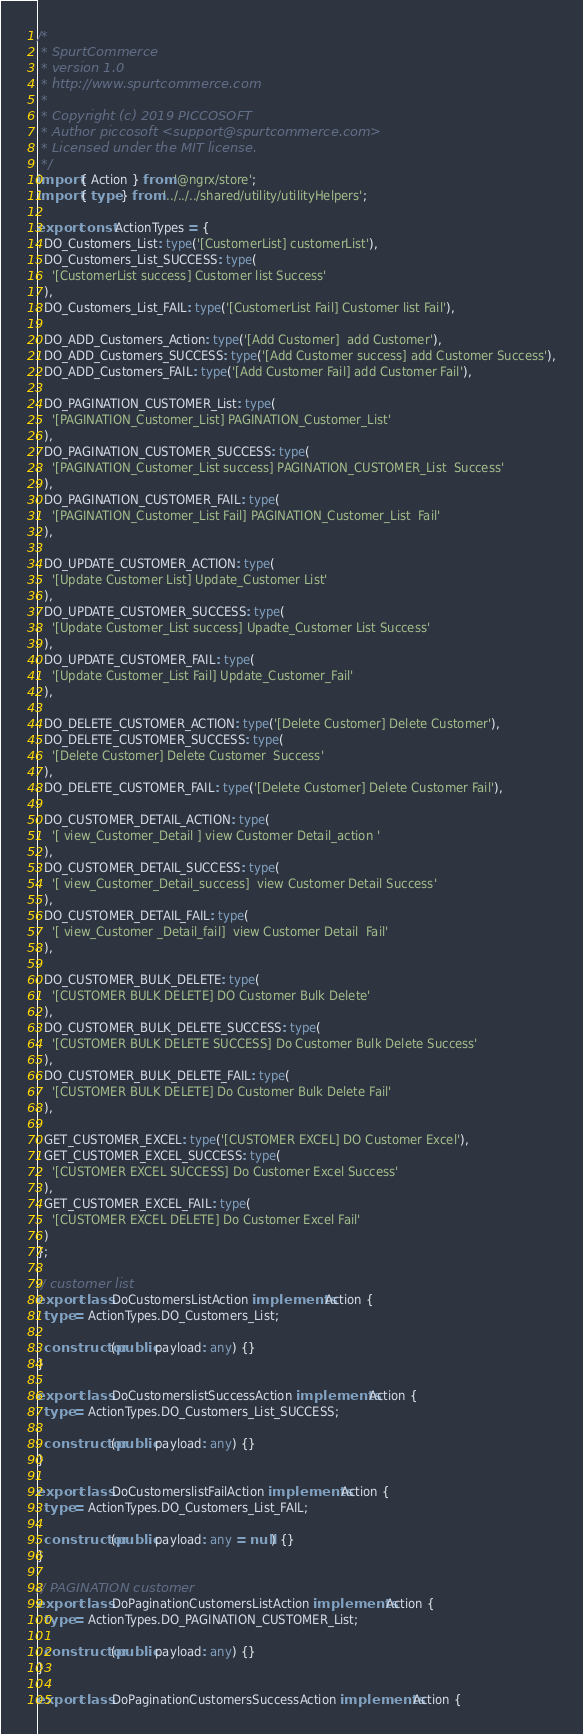Convert code to text. <code><loc_0><loc_0><loc_500><loc_500><_TypeScript_>/*
 * SpurtCommerce
 * version 1.0
 * http://www.spurtcommerce.com
 *
 * Copyright (c) 2019 PICCOSOFT
 * Author piccosoft <support@spurtcommerce.com>
 * Licensed under the MIT license.
 */
import { Action } from '@ngrx/store';
import { type } from '../../../shared/utility/utilityHelpers';

export const ActionTypes = {
  DO_Customers_List: type('[CustomerList] customerList'),
  DO_Customers_List_SUCCESS: type(
    '[CustomerList success] Customer list Success'
  ),
  DO_Customers_List_FAIL: type('[CustomerList Fail] Customer list Fail'),

  DO_ADD_Customers_Action: type('[Add Customer]  add Customer'),
  DO_ADD_Customers_SUCCESS: type('[Add Customer success] add Customer Success'),
  DO_ADD_Customers_FAIL: type('[Add Customer Fail] add Customer Fail'),

  DO_PAGINATION_CUSTOMER_List: type(
    '[PAGINATION_Customer_List] PAGINATION_Customer_List'
  ),
  DO_PAGINATION_CUSTOMER_SUCCESS: type(
    '[PAGINATION_Customer_List success] PAGINATION_CUSTOMER_List  Success'
  ),
  DO_PAGINATION_CUSTOMER_FAIL: type(
    '[PAGINATION_Customer_List Fail] PAGINATION_Customer_List  Fail'
  ),

  DO_UPDATE_CUSTOMER_ACTION: type(
    '[Update Customer List] Update_Customer List'
  ),
  DO_UPDATE_CUSTOMER_SUCCESS: type(
    '[Update Customer_List success] Upadte_Customer List Success'
  ),
  DO_UPDATE_CUSTOMER_FAIL: type(
    '[Update Customer_List Fail] Update_Customer_Fail'
  ),

  DO_DELETE_CUSTOMER_ACTION: type('[Delete Customer] Delete Customer'),
  DO_DELETE_CUSTOMER_SUCCESS: type(
    '[Delete Customer] Delete Customer  Success'
  ),
  DO_DELETE_CUSTOMER_FAIL: type('[Delete Customer] Delete Customer Fail'),

  DO_CUSTOMER_DETAIL_ACTION: type(
    '[ view_Customer_Detail ] view Customer Detail_action '
  ),
  DO_CUSTOMER_DETAIL_SUCCESS: type(
    '[ view_Customer_Detail_success]  view Customer Detail Success'
  ),
  DO_CUSTOMER_DETAIL_FAIL: type(
    '[ view_Customer _Detail_fail]  view Customer Detail  Fail'
  ),

  DO_CUSTOMER_BULK_DELETE: type(
    '[CUSTOMER BULK DELETE] DO Customer Bulk Delete'
  ),
  DO_CUSTOMER_BULK_DELETE_SUCCESS: type(
    '[CUSTOMER BULK DELETE SUCCESS] Do Customer Bulk Delete Success'
  ),
  DO_CUSTOMER_BULK_DELETE_FAIL: type(
    '[CUSTOMER BULK DELETE] Do Customer Bulk Delete Fail'
  ),

  GET_CUSTOMER_EXCEL: type('[CUSTOMER EXCEL] DO Customer Excel'),
  GET_CUSTOMER_EXCEL_SUCCESS: type(
    '[CUSTOMER EXCEL SUCCESS] Do Customer Excel Success'
  ),
  GET_CUSTOMER_EXCEL_FAIL: type(
    '[CUSTOMER EXCEL DELETE] Do Customer Excel Fail'
  )
};

// customer list
export class DoCustomersListAction implements Action {
  type = ActionTypes.DO_Customers_List;

  constructor(public payload: any) {}
}

export class DoCustomerslistSuccessAction implements Action {
  type = ActionTypes.DO_Customers_List_SUCCESS;

  constructor(public payload: any) {}
}

export class DoCustomerslistFailAction implements Action {
  type = ActionTypes.DO_Customers_List_FAIL;

  constructor(public payload: any = null) {}
}

// PAGINATION customer
export class DoPaginationCustomersListAction implements Action {
  type = ActionTypes.DO_PAGINATION_CUSTOMER_List;

  constructor(public payload: any) {}
}

export class DoPaginationCustomersSuccessAction implements Action {</code> 